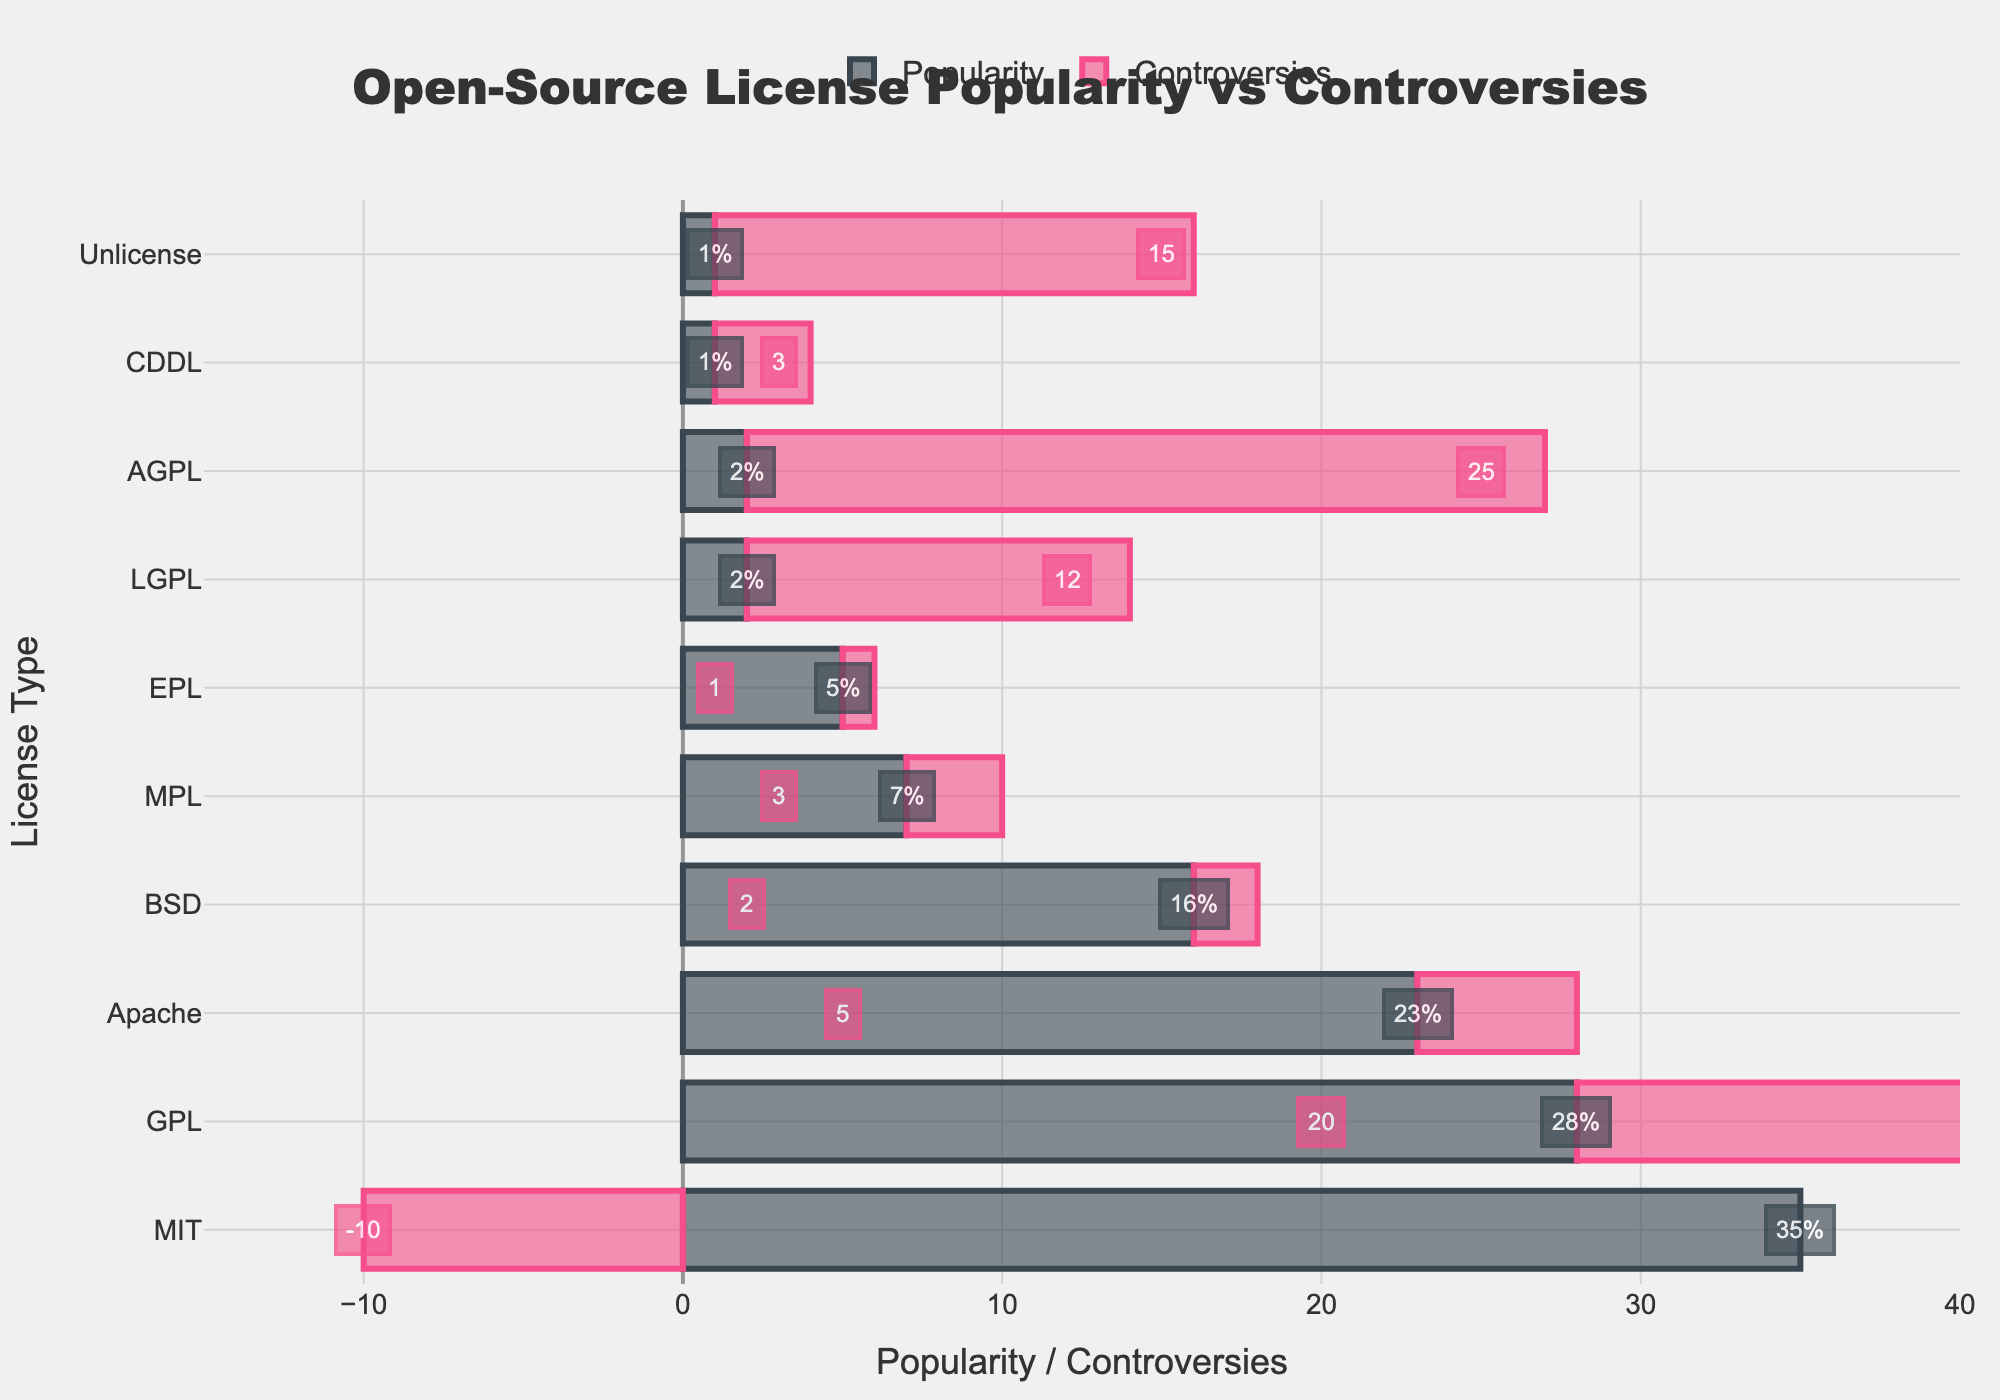Which license has the highest popularity? The license with the highest popularity can be determined by identifying the bar with the longest length in the 'Popularity' category. This corresponds to the MIT license, which has the longest bar.
Answer: MIT Which license is associated with the highest number of controversies? The license with the highest number of controversies can be found by identifying the bar with the longest length in the 'Controversies' category. The AGPL license has the longest bar.
Answer: AGPL How many more projects use the MIT license compared to the GPL license? First, find the number of projects using the MIT license, which is 15,000. Then, find the number of projects using the GPL license, which is 12,000. Subtract the number of GPL projects from the number of MIT projects: 15,000 - 12,000 = 3,000.
Answer: 3,000 Which license has more controversies, the BSD or the MPL license? Compare the 'Controversies' bars for both BSD and MPL licenses. The MPL license has more controversies (3) compared to the BSD license (2).
Answer: MPL What is the sum of the popularity percentages of MIT and Apache licenses? Find the popularity percentages for MIT (35%) and Apache (23%), and sum them up: 35% + 23% = 58%.
Answer: 58% What is the range of the controversy scores among the licenses? Identify the minimum and maximum controversy scores. The minimum controversy score is -10 (MIT), and the maximum is 25 (AGPL). The range is calculated as the difference between the maximum and minimum: 25 - (-10) = 35.
Answer: 35 Is the popularity of the Apache license greater than that of the BSD license? Compare the 'Popularity' bars for Apache and BSD. The Apache license has a popularity of 23%, while the BSD license has 16%. Therefore, the Apache license is more popular.
Answer: Yes Which license has the least number of projects associated with it? Find the license with the smallest number of projects by looking at the 'Projects' data. The Unlicense has the least number of projects (400).
Answer: Unlicense How does the controversy score of GPL compare to that of MIT? Compare the controversy scores for GPL (20) and MIT (-10). The GPL has a higher controversy score than MIT.
Answer: GPL has a higher score 